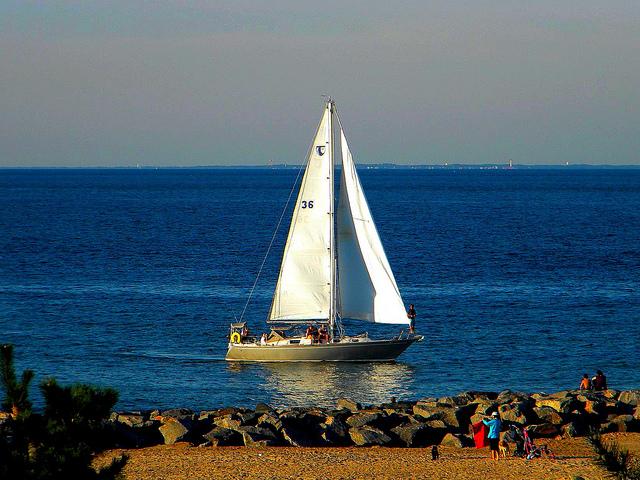What is the number on the sail?
Quick response, please. 36. What kind of boat is this?
Write a very short answer. Sailboat. Are there big waves present?
Keep it brief. No. Is there smoke coming from the boat?
Write a very short answer. No. 